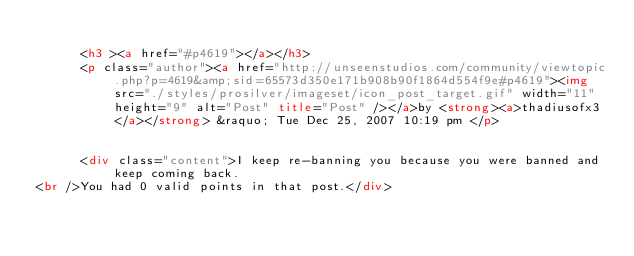<code> <loc_0><loc_0><loc_500><loc_500><_HTML_>			
			<h3 ><a href="#p4619"></a></h3>
			<p class="author"><a href="http://unseenstudios.com/community/viewtopic.php?p=4619&amp;sid=65573d350e171b908b90f1864d554f9e#p4619"><img src="./styles/prosilver/imageset/icon_post_target.gif" width="11" height="9" alt="Post" title="Post" /></a>by <strong><a>thadiusofx3</a></strong> &raquo; Tue Dec 25, 2007 10:19 pm </p>

			
			<div class="content">I keep re-banning you because you were banned and keep coming back.
<br />You had 0 valid points in that post.</div>
</code> 